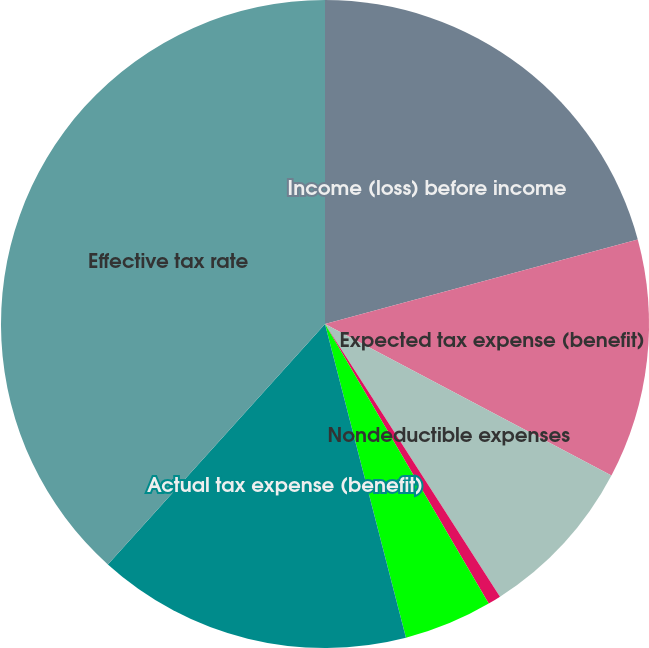Convert chart to OTSL. <chart><loc_0><loc_0><loc_500><loc_500><pie_chart><fcel>Income (loss) before income<fcel>Expected tax expense (benefit)<fcel>Nondeductible expenses<fcel>State income taxes<fcel>Other - net<fcel>Actual tax expense (benefit)<fcel>Effective tax rate<nl><fcel>20.8%<fcel>11.94%<fcel>8.18%<fcel>0.65%<fcel>4.41%<fcel>15.71%<fcel>38.31%<nl></chart> 